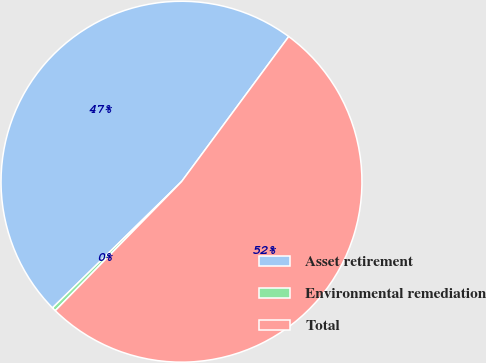Convert chart to OTSL. <chart><loc_0><loc_0><loc_500><loc_500><pie_chart><fcel>Asset retirement<fcel>Environmental remediation<fcel>Total<nl><fcel>47.45%<fcel>0.35%<fcel>52.2%<nl></chart> 